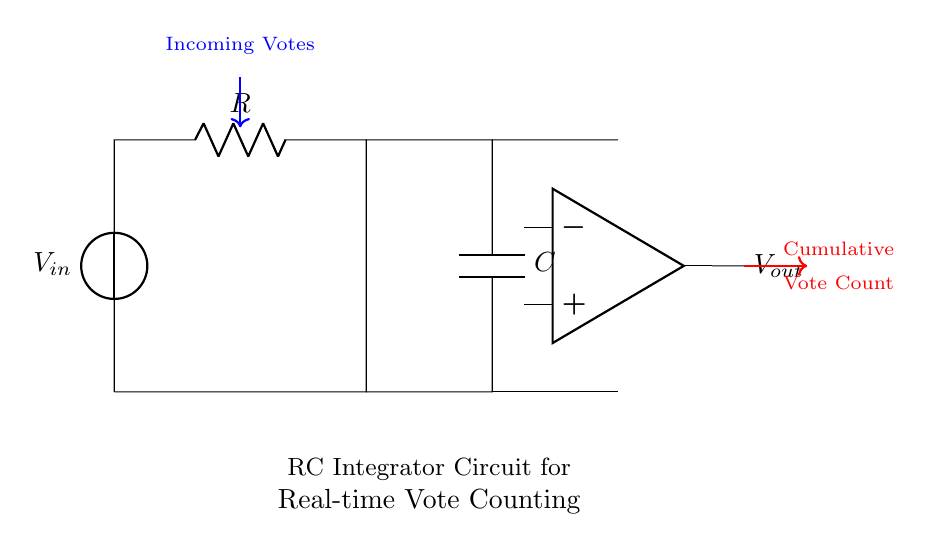What is the total number of components in the circuit? The circuit consists of four main components: one voltage source, one resistor, one capacitor, and one operational amplifier. Adding these gives us a total of four components.
Answer: Four What is the role of the capacitor in this circuit? The capacitor in an RC integrator circuit plays the role of accumulating electrical charge over time, which helps in producing a voltage that is proportional to the cumulative input votes. This integrates the incoming signal.
Answer: Accumulating charge What is the output voltage labeled as in the circuit? The output voltage is indicated as "V out," which is the voltage that represents the cumulative vote count after integration by the circuit.
Answer: V out How does the capacitor affect the rate of change in output voltage? The capacitor in the circuit introduces a time constant that affects how quickly the output voltage changes in response to input voltage variations. A larger capacitor slows down the rate of change, producing a smoother output signal.
Answer: Slows down change What type of circuit is depicted in the diagram? The depicted circuit is an RC integrator circuit, which is characterized by its combination of resistors and capacitors to provide integration functionality. This is primarily used for processing varied temporal signals.
Answer: RC integrator What is the primary function of the operational amplifier in this circuit? The operational amplifier amplifies the voltage across the capacitor, ensuring that the output voltage (V out) accurately reflects the integrated signal of incoming votes, thus providing a clear representation of cumulative results.
Answer: Amplifying voltage 